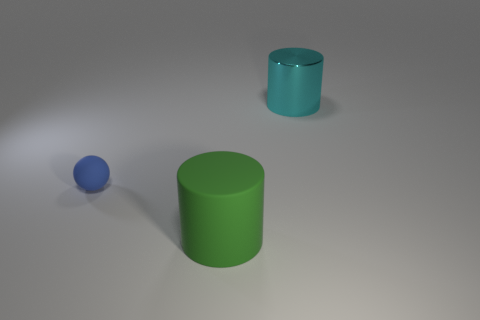Add 3 matte cylinders. How many objects exist? 6 Subtract all cylinders. How many objects are left? 1 Subtract all matte cylinders. Subtract all brown objects. How many objects are left? 2 Add 3 green matte cylinders. How many green matte cylinders are left? 4 Add 2 large green objects. How many large green objects exist? 3 Subtract 0 yellow cubes. How many objects are left? 3 